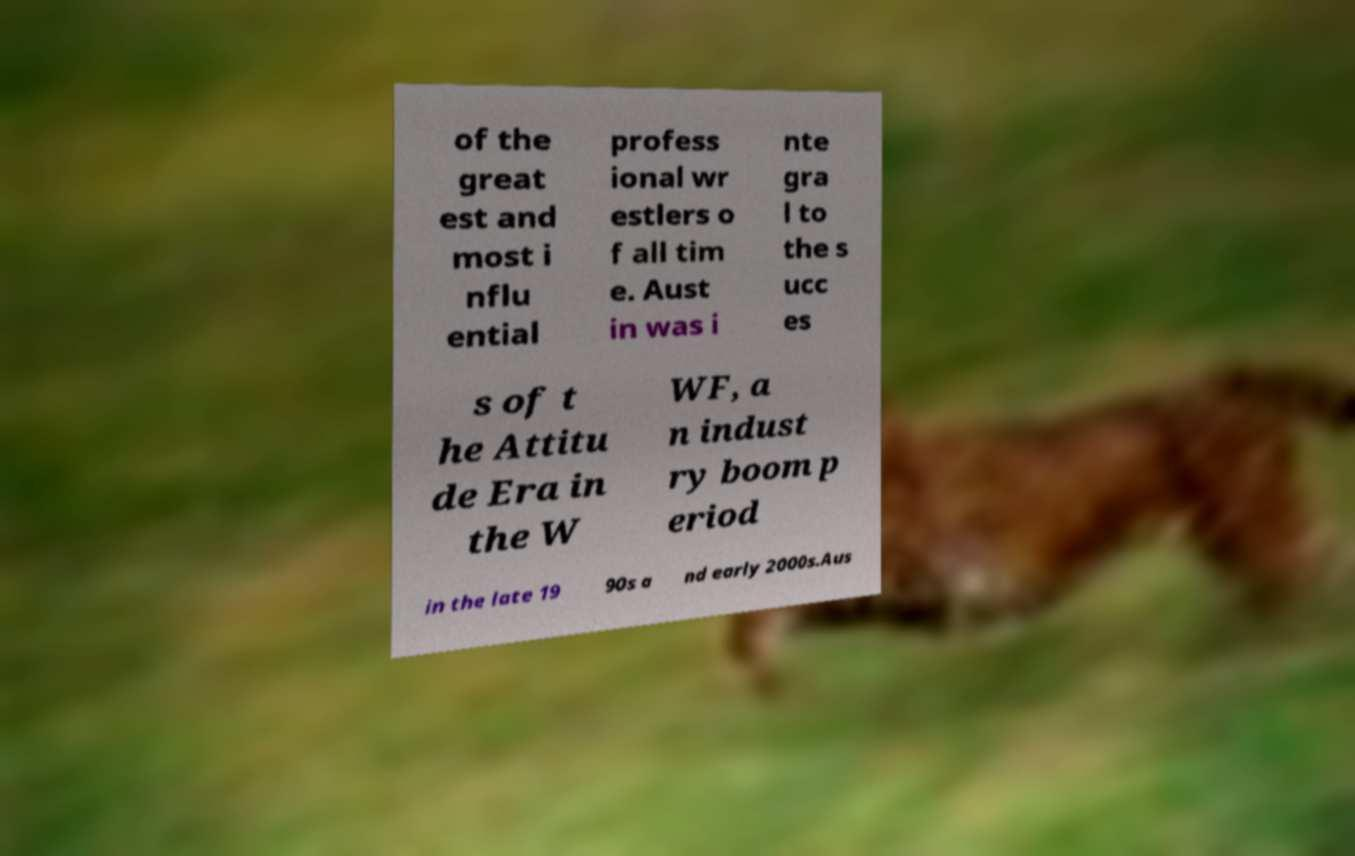For documentation purposes, I need the text within this image transcribed. Could you provide that? of the great est and most i nflu ential profess ional wr estlers o f all tim e. Aust in was i nte gra l to the s ucc es s of t he Attitu de Era in the W WF, a n indust ry boom p eriod in the late 19 90s a nd early 2000s.Aus 